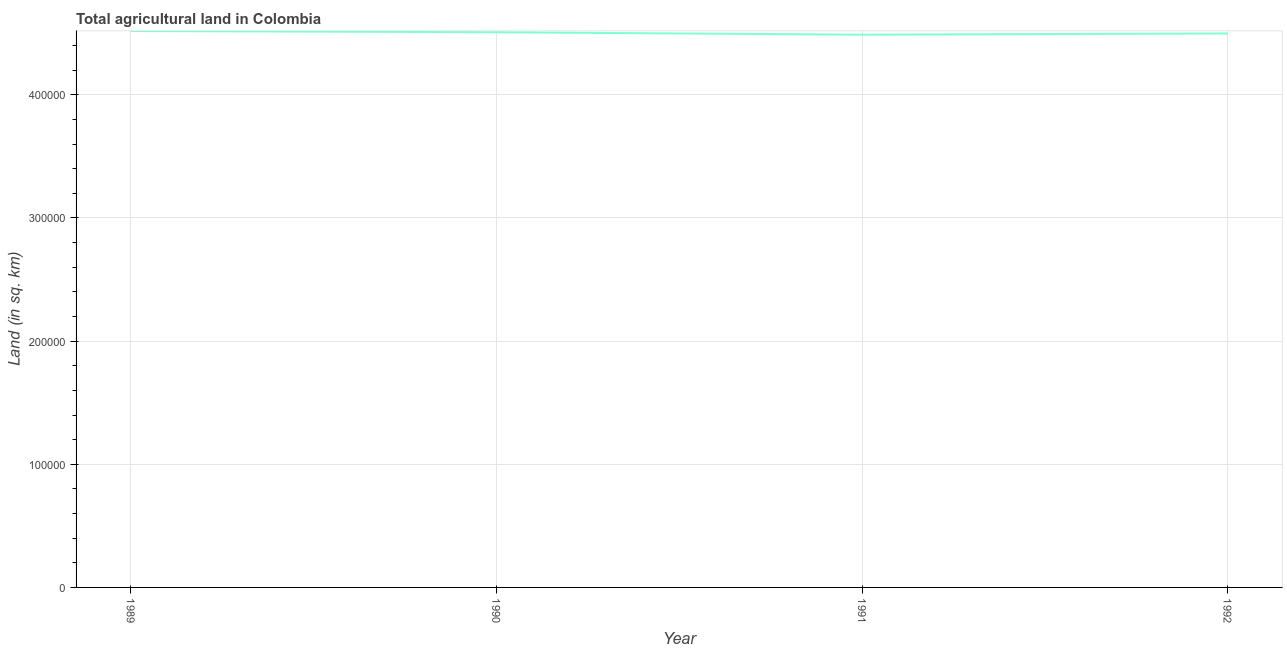What is the agricultural land in 1990?
Your answer should be very brief. 4.51e+05. Across all years, what is the maximum agricultural land?
Your answer should be compact. 4.52e+05. Across all years, what is the minimum agricultural land?
Ensure brevity in your answer.  4.49e+05. In which year was the agricultural land maximum?
Your answer should be very brief. 1989. In which year was the agricultural land minimum?
Make the answer very short. 1991. What is the sum of the agricultural land?
Your answer should be very brief. 1.80e+06. What is the difference between the agricultural land in 1990 and 1992?
Offer a very short reply. 1000. What is the average agricultural land per year?
Provide a succinct answer. 4.50e+05. What is the median agricultural land?
Offer a very short reply. 4.50e+05. In how many years, is the agricultural land greater than 420000 sq. km?
Provide a short and direct response. 4. Do a majority of the years between 1989 and 1992 (inclusive) have agricultural land greater than 320000 sq. km?
Offer a terse response. Yes. What is the ratio of the agricultural land in 1989 to that in 1992?
Offer a very short reply. 1. What is the difference between the highest and the second highest agricultural land?
Keep it short and to the point. 1000. Is the sum of the agricultural land in 1989 and 1990 greater than the maximum agricultural land across all years?
Offer a terse response. Yes. What is the difference between the highest and the lowest agricultural land?
Your answer should be compact. 2990. Are the values on the major ticks of Y-axis written in scientific E-notation?
Your answer should be compact. No. Does the graph contain any zero values?
Ensure brevity in your answer.  No. Does the graph contain grids?
Provide a short and direct response. Yes. What is the title of the graph?
Your answer should be compact. Total agricultural land in Colombia. What is the label or title of the Y-axis?
Make the answer very short. Land (in sq. km). What is the Land (in sq. km) of 1989?
Make the answer very short. 4.52e+05. What is the Land (in sq. km) in 1990?
Provide a succinct answer. 4.51e+05. What is the Land (in sq. km) of 1991?
Provide a short and direct response. 4.49e+05. What is the Land (in sq. km) in 1992?
Your response must be concise. 4.50e+05. What is the difference between the Land (in sq. km) in 1989 and 1991?
Provide a short and direct response. 2990. What is the difference between the Land (in sq. km) in 1989 and 1992?
Your answer should be very brief. 2000. What is the difference between the Land (in sq. km) in 1990 and 1991?
Ensure brevity in your answer.  1990. What is the difference between the Land (in sq. km) in 1991 and 1992?
Provide a succinct answer. -990. What is the ratio of the Land (in sq. km) in 1989 to that in 1991?
Provide a short and direct response. 1.01. What is the ratio of the Land (in sq. km) in 1989 to that in 1992?
Your response must be concise. 1. What is the ratio of the Land (in sq. km) in 1990 to that in 1991?
Offer a terse response. 1. What is the ratio of the Land (in sq. km) in 1990 to that in 1992?
Your response must be concise. 1. 